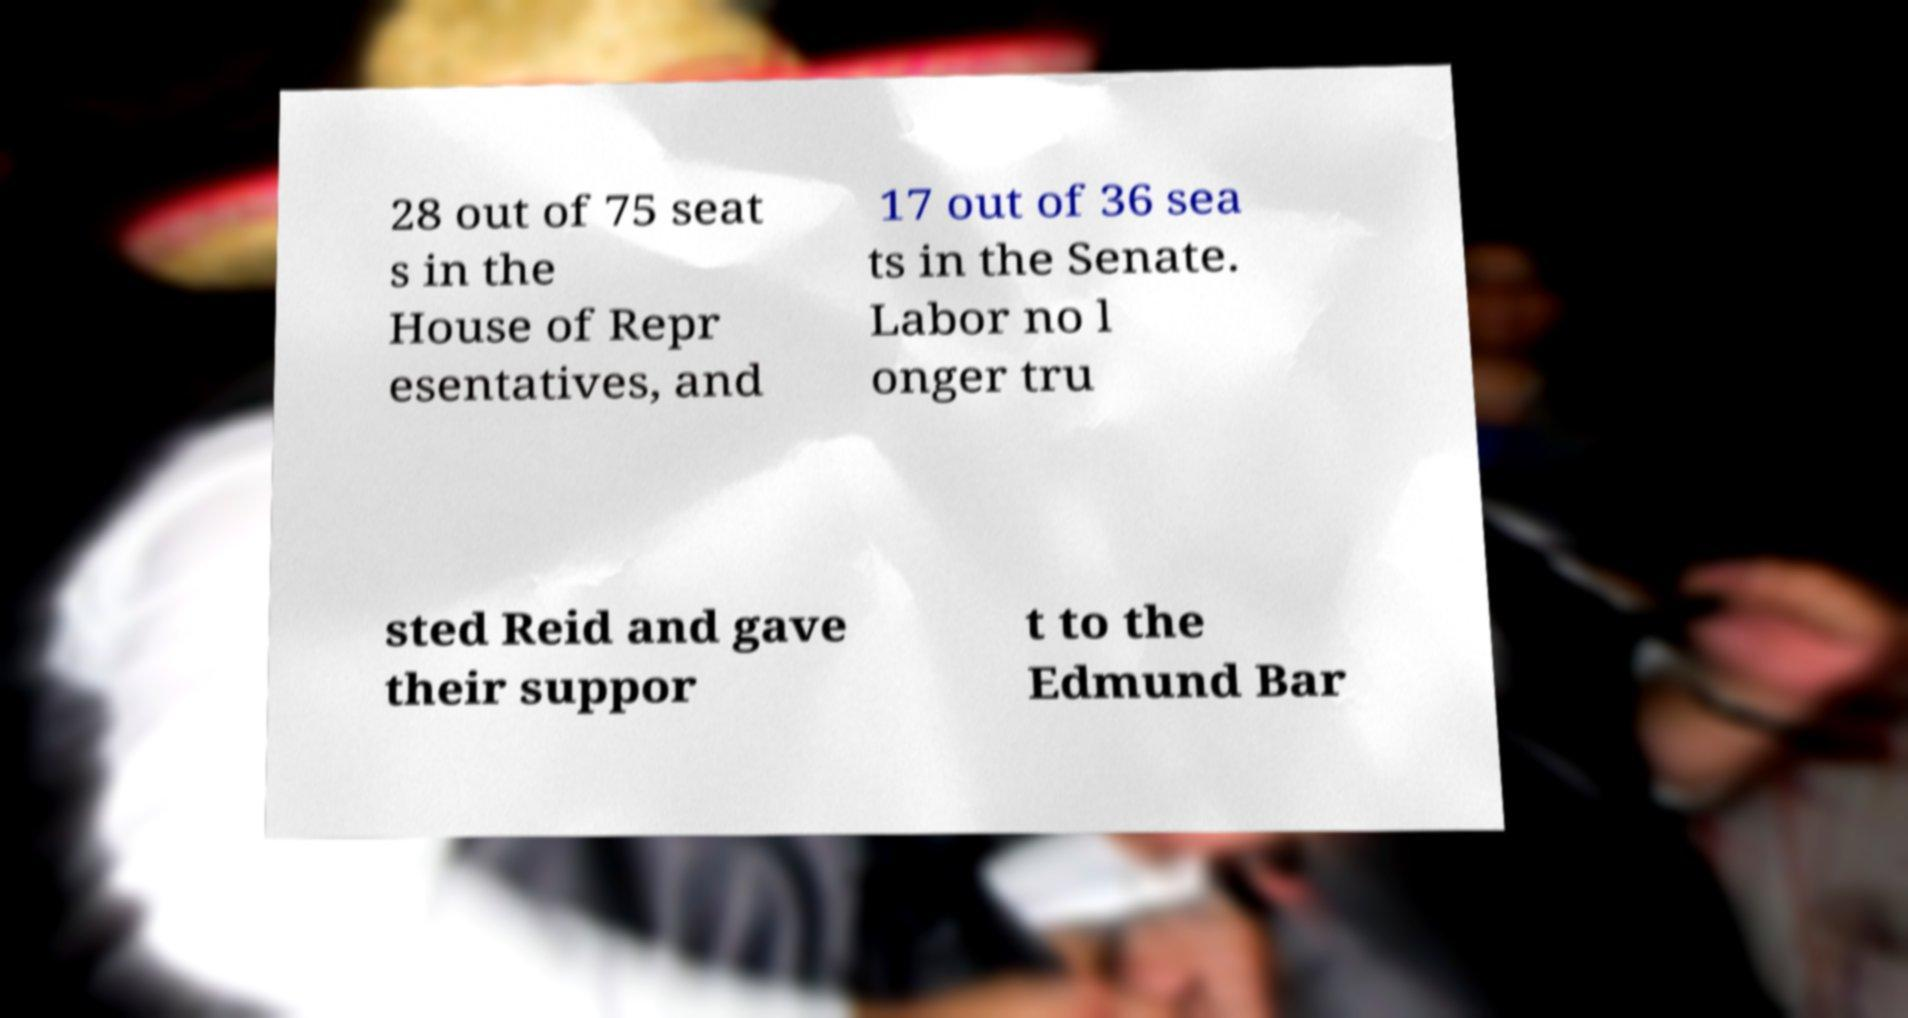Can you read and provide the text displayed in the image?This photo seems to have some interesting text. Can you extract and type it out for me? 28 out of 75 seat s in the House of Repr esentatives, and 17 out of 36 sea ts in the Senate. Labor no l onger tru sted Reid and gave their suppor t to the Edmund Bar 